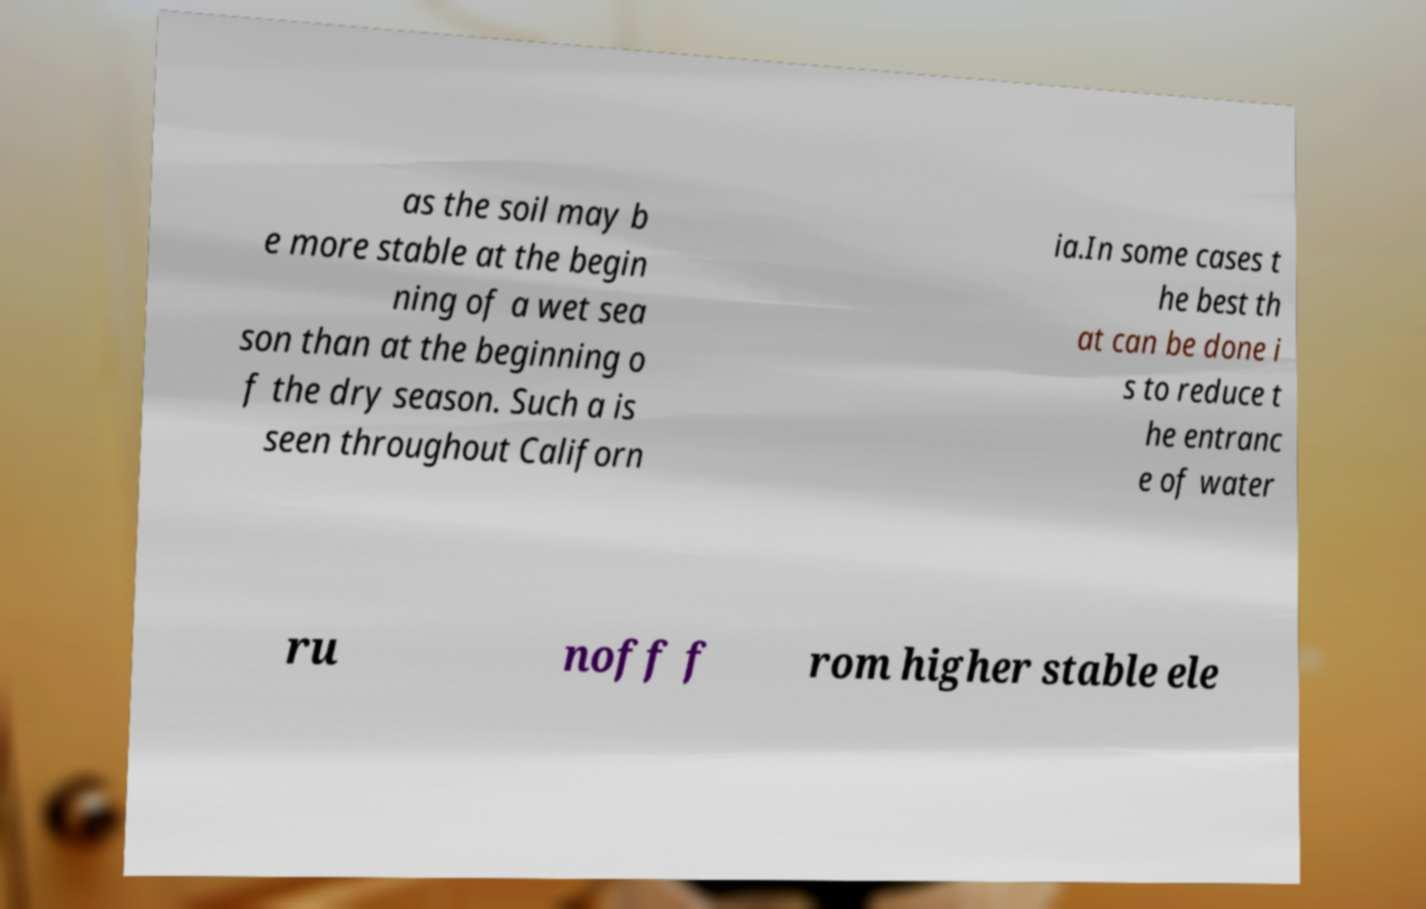Can you accurately transcribe the text from the provided image for me? as the soil may b e more stable at the begin ning of a wet sea son than at the beginning o f the dry season. Such a is seen throughout Californ ia.In some cases t he best th at can be done i s to reduce t he entranc e of water ru noff f rom higher stable ele 